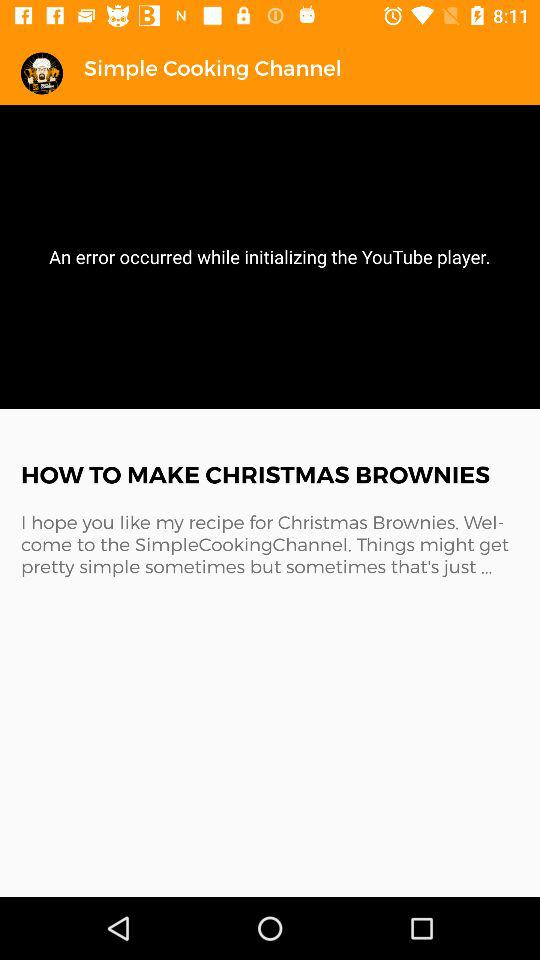What is the name of the application? The name of the application is "Simple Cooking Channel". 